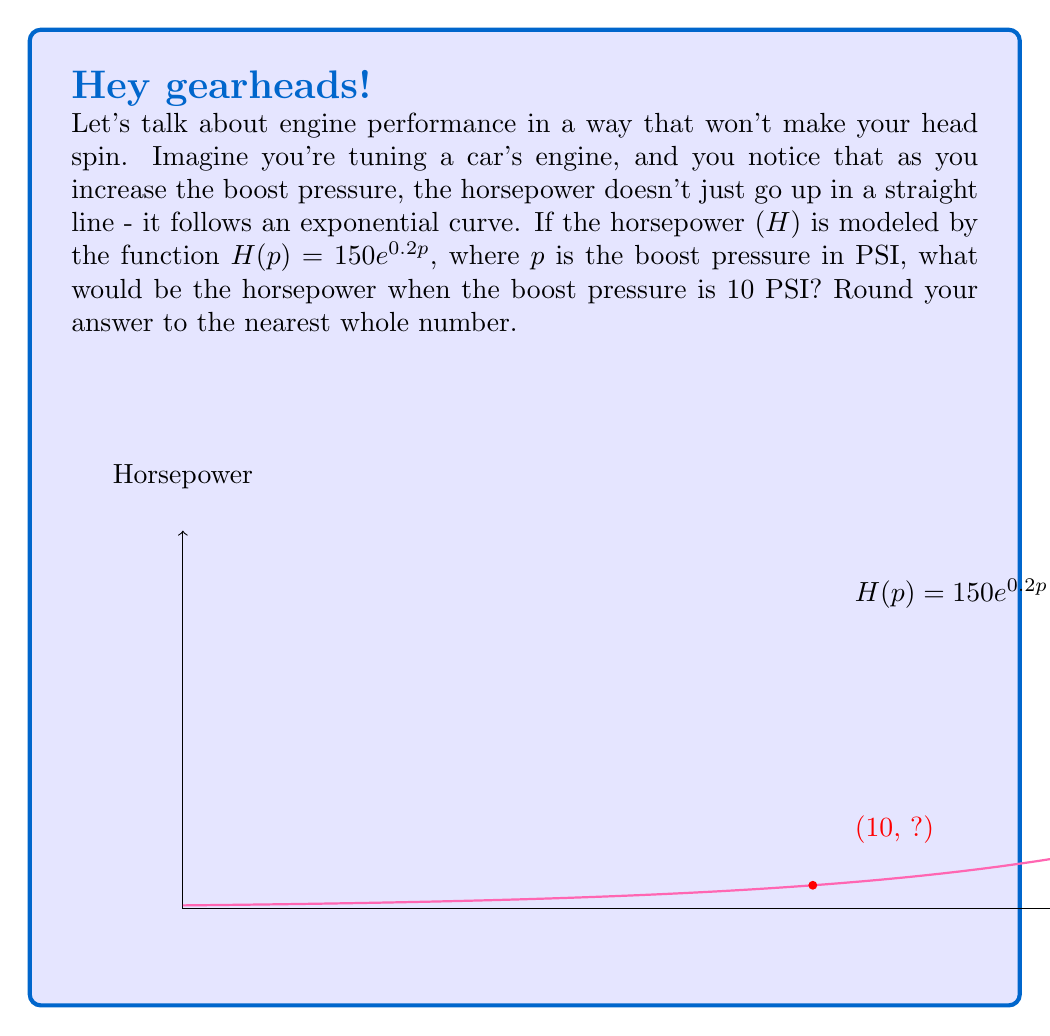Can you solve this math problem? Let's break this down step-by-step:

1) We're given the function $H(p) = 150e^{0.2p}$, where:
   - H is the horsepower
   - p is the boost pressure in PSI
   - e is the mathematical constant (approximately 2.71828)

2) We need to find H when p = 10 PSI.

3) Let's substitute p = 10 into our function:
   $H(10) = 150e^{0.2(10)}$

4) Simplify the exponent:
   $H(10) = 150e^2$

5) Now, we need to calculate $e^2$:
   $e^2 \approx 2.71828^2 \approx 7.3891$

6) Multiply this by 150:
   $H(10) = 150 * 7.3891 = 1108.365$

7) Rounding to the nearest whole number:
   $H(10) \approx 1108$ horsepower
Answer: 1108 horsepower 